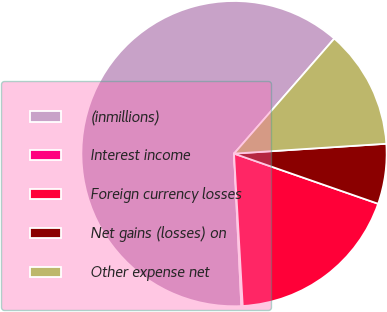Convert chart. <chart><loc_0><loc_0><loc_500><loc_500><pie_chart><fcel>(inmillions)<fcel>Interest income<fcel>Foreign currency losses<fcel>Net gains (losses) on<fcel>Other expense net<nl><fcel>62.17%<fcel>0.15%<fcel>18.76%<fcel>6.36%<fcel>12.56%<nl></chart> 